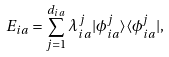Convert formula to latex. <formula><loc_0><loc_0><loc_500><loc_500>E _ { i a } = \sum _ { j = 1 } ^ { d _ { i a } } { \lambda ^ { j } _ { i a } | \phi ^ { j } _ { i a } \rangle \langle \phi ^ { j } _ { i a } | } ,</formula> 